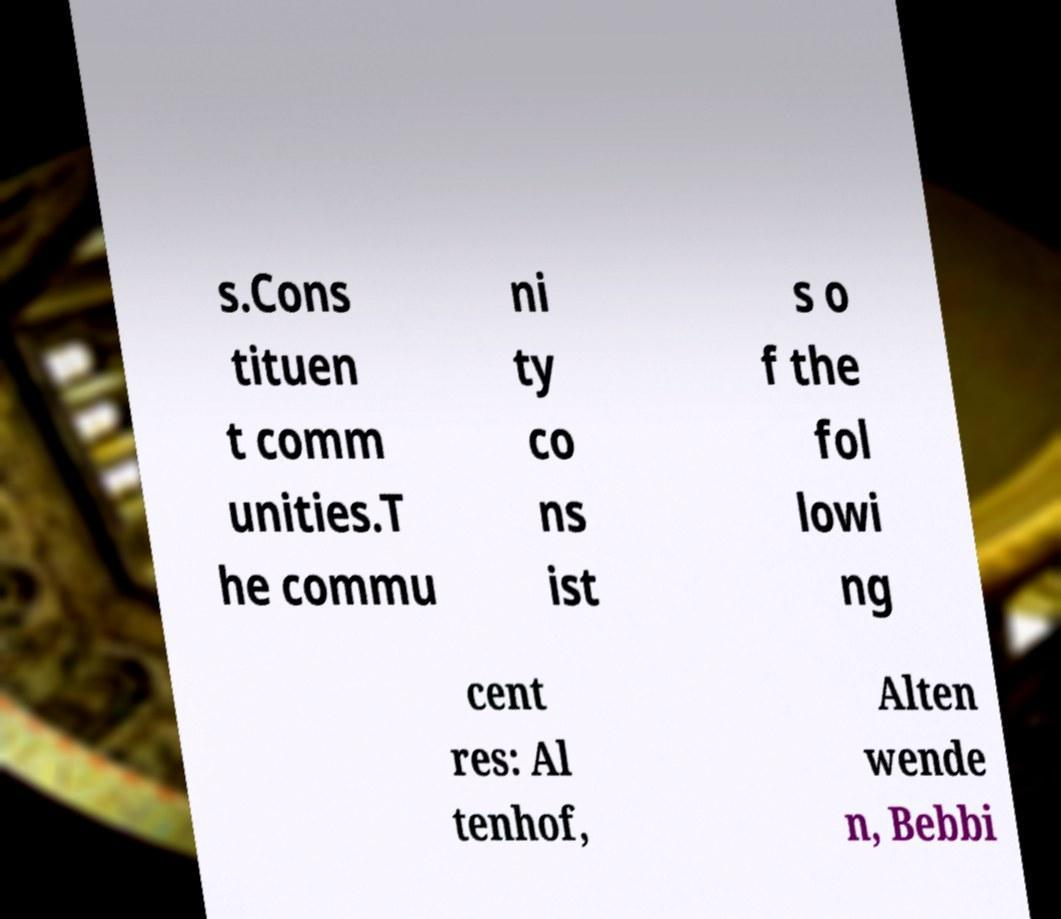For documentation purposes, I need the text within this image transcribed. Could you provide that? s.Cons tituen t comm unities.T he commu ni ty co ns ist s o f the fol lowi ng cent res: Al tenhof, Alten wende n, Bebbi 